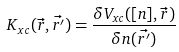<formula> <loc_0><loc_0><loc_500><loc_500>K _ { x c } ( \vec { r } , \vec { r ^ { \prime } } ) = \frac { \delta V _ { x c } ( [ n ] , \vec { r } ) } { \delta n ( \vec { r ^ { \prime } } ) }</formula> 